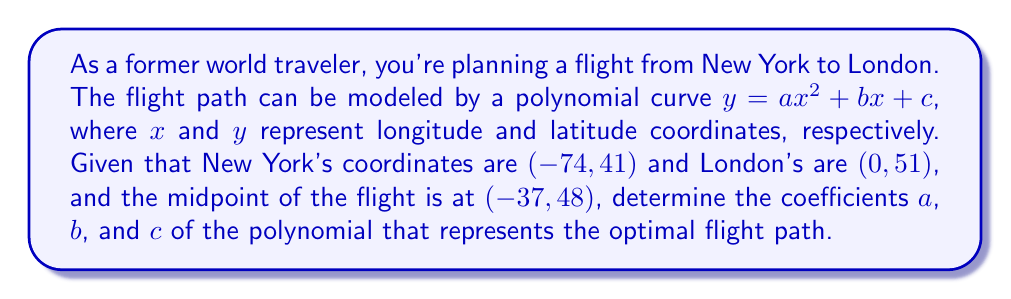Give your solution to this math problem. Let's approach this step-by-step:

1) We have three points on our polynomial curve:
   New York: $(-74, 41)$
   Midpoint: $(-37, 48)$
   London: $(0, 51)$

2) We can substitute these points into the general equation $y = ax^2 + bx + c$:

   $41 = a(-74)^2 + b(-74) + c$ ... (1)
   $48 = a(-37)^2 + b(-37) + c$ ... (2)
   $51 = a(0)^2 + b(0) + c$     ... (3)

3) From equation (3), we can immediately see that $c = 51$

4) Subtracting equation (3) from (1) and (2):

   $-10 = 5476a - 74b$ ... (4)
   $-3 = 1369a - 37b$  ... (5)

5) Multiply equation (5) by 2:

   $-6 = 2738a - 74b$  ... (6)

6) Subtract equation (6) from (4):

   $-4 = 2738a$

7) Solve for $a$:

   $a = \frac{-4}{2738} \approx -0.00146$

8) Substitute this value of $a$ into equation (5):

   $-3 = 1369(-0.00146) - 37b$
   $-3 = -2 - 37b$
   $-1 = -37b$
   $b = \frac{1}{37} \approx 0.027$

9) Therefore, the coefficients are:
   $a \approx -0.00146$
   $b \approx 0.027$
   $c = 51$
Answer: $a \approx -0.00146$, $b \approx 0.027$, $c = 51$ 